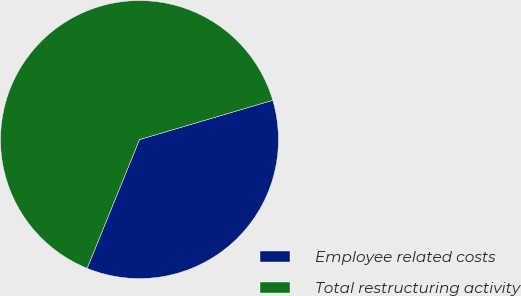<chart> <loc_0><loc_0><loc_500><loc_500><pie_chart><fcel>Employee related costs<fcel>Total restructuring activity<nl><fcel>35.71%<fcel>64.29%<nl></chart> 